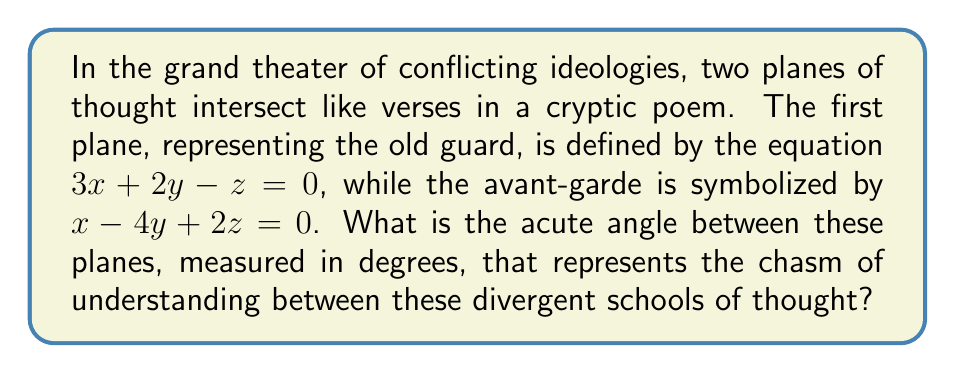Teach me how to tackle this problem. To find the angle between two intersecting planes, we follow these steps:

1) The angle between two planes is the same as the angle between their normal vectors. The normal vector of a plane $ax + by + cz + d = 0$ is $(a, b, c)$.

2) For the first plane $3x + 2y - z = 0$, the normal vector is $\vec{n_1} = (3, 2, -1)$.
   For the second plane $x - 4y + 2z = 0$, the normal vector is $\vec{n_2} = (1, -4, 2)$.

3) The angle $\theta$ between these vectors is given by the dot product formula:

   $$\cos \theta = \frac{\vec{n_1} \cdot \vec{n_2}}{|\vec{n_1}| |\vec{n_2}|}$$

4) Calculate the dot product $\vec{n_1} \cdot \vec{n_2}$:
   $$(3)(1) + (2)(-4) + (-1)(2) = 3 - 8 - 2 = -7$$

5) Calculate the magnitudes:
   $$|\vec{n_1}| = \sqrt{3^2 + 2^2 + (-1)^2} = \sqrt{14}$$
   $$|\vec{n_2}| = \sqrt{1^2 + (-4)^2 + 2^2} = \sqrt{21}$$

6) Substitute into the formula:
   $$\cos \theta = \frac{-7}{\sqrt{14} \sqrt{21}}$$

7) Take the inverse cosine (arccos) of both sides:
   $$\theta = \arccos\left(\frac{-7}{\sqrt{14} \sqrt{21}}\right)$$

8) Convert to degrees:
   $$\theta = \arccos\left(\frac{-7}{\sqrt{14} \sqrt{21}}\right) \cdot \frac{180}{\pi} \approx 110.73^\circ$$

9) Since we want the acute angle, subtract from 180°:
   $$180^\circ - 110.73^\circ \approx 69.27^\circ$$
Answer: $69.27^\circ$ 